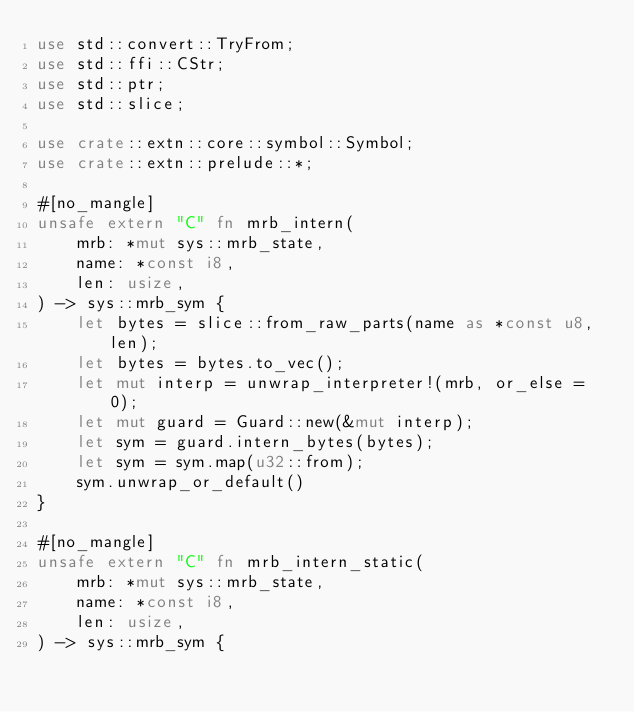<code> <loc_0><loc_0><loc_500><loc_500><_Rust_>use std::convert::TryFrom;
use std::ffi::CStr;
use std::ptr;
use std::slice;

use crate::extn::core::symbol::Symbol;
use crate::extn::prelude::*;

#[no_mangle]
unsafe extern "C" fn mrb_intern(
    mrb: *mut sys::mrb_state,
    name: *const i8,
    len: usize,
) -> sys::mrb_sym {
    let bytes = slice::from_raw_parts(name as *const u8, len);
    let bytes = bytes.to_vec();
    let mut interp = unwrap_interpreter!(mrb, or_else = 0);
    let mut guard = Guard::new(&mut interp);
    let sym = guard.intern_bytes(bytes);
    let sym = sym.map(u32::from);
    sym.unwrap_or_default()
}

#[no_mangle]
unsafe extern "C" fn mrb_intern_static(
    mrb: *mut sys::mrb_state,
    name: *const i8,
    len: usize,
) -> sys::mrb_sym {</code> 